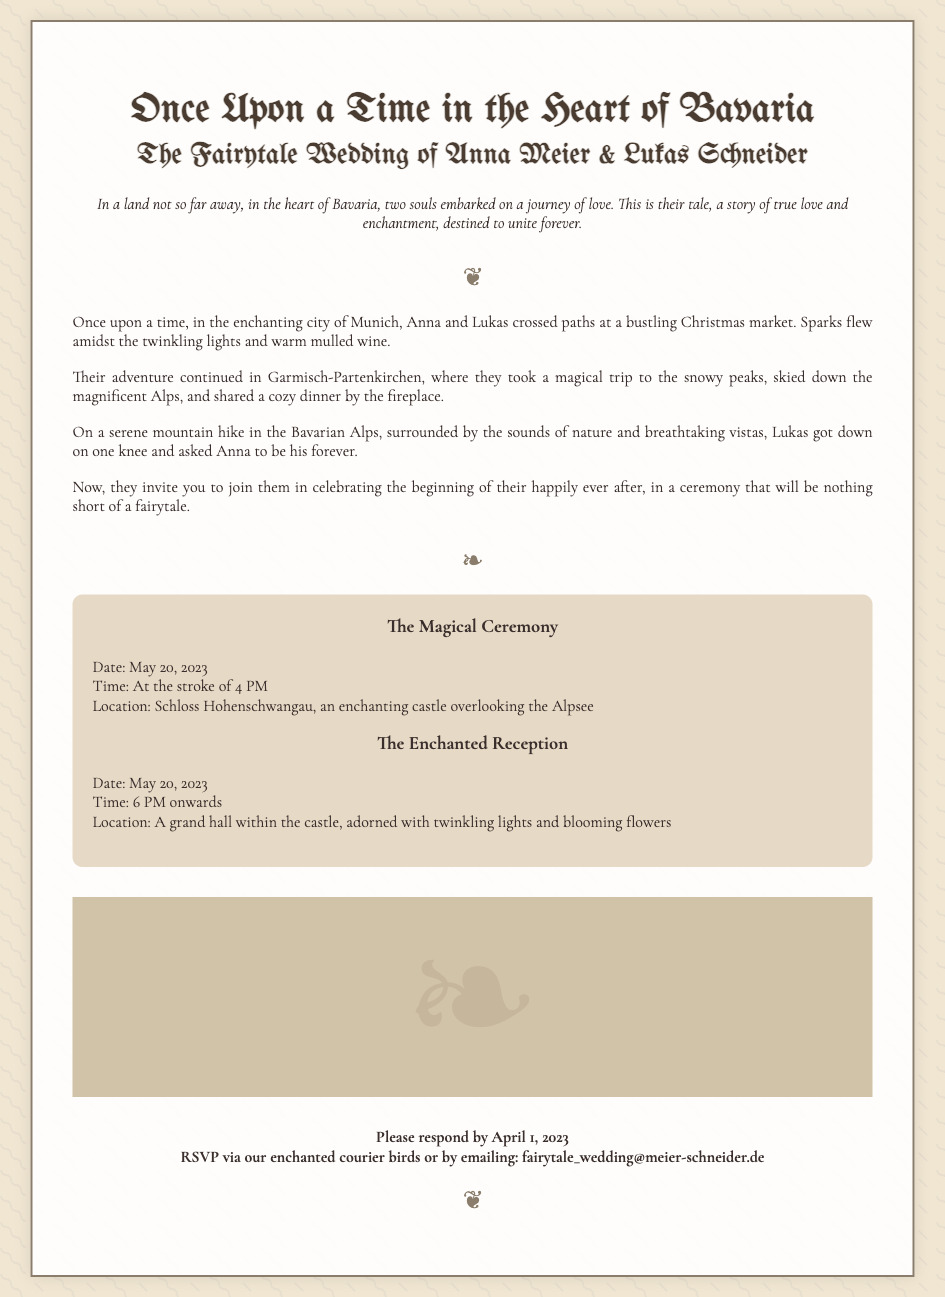What is the title of the wedding? The title of the wedding is mentioned prominently at the top of the invitation.
Answer: Anna & Lukas' Märchenhochzeit Who are the couple getting married? The couple’s names are highlighted in the heading of the invitation.
Answer: Anna Meier & Lukas Schneider What date is the magical ceremony scheduled for? The invitation specifies the date for the ceremony within the details section.
Answer: May 20, 2023 What time does the reception start? The starting time for the reception is found in the details section.
Answer: 6 PM onwards Where is the location of the magical ceremony? The location of the ceremony is stated clearly in the details part of the invitation.
Answer: Schloss Hohenschwangau What was the setting where Anna and Lukas first met? This information is detailed in the story section of the invitation.
Answer: Christmas market What did Lukas ask Anna during their mountain hike? This question refers to a significant moment described in the story section.
Answer: To be his forever What should guests use to respond to the RSVP? The invitation mentions two methods for RSVPing in the RSVP section.
Answer: Enchanted courier birds or email What is the backdrop of the wedding reception? This information about the reception's decor is included in the details section.
Answer: Twinkling lights and blooming flowers 